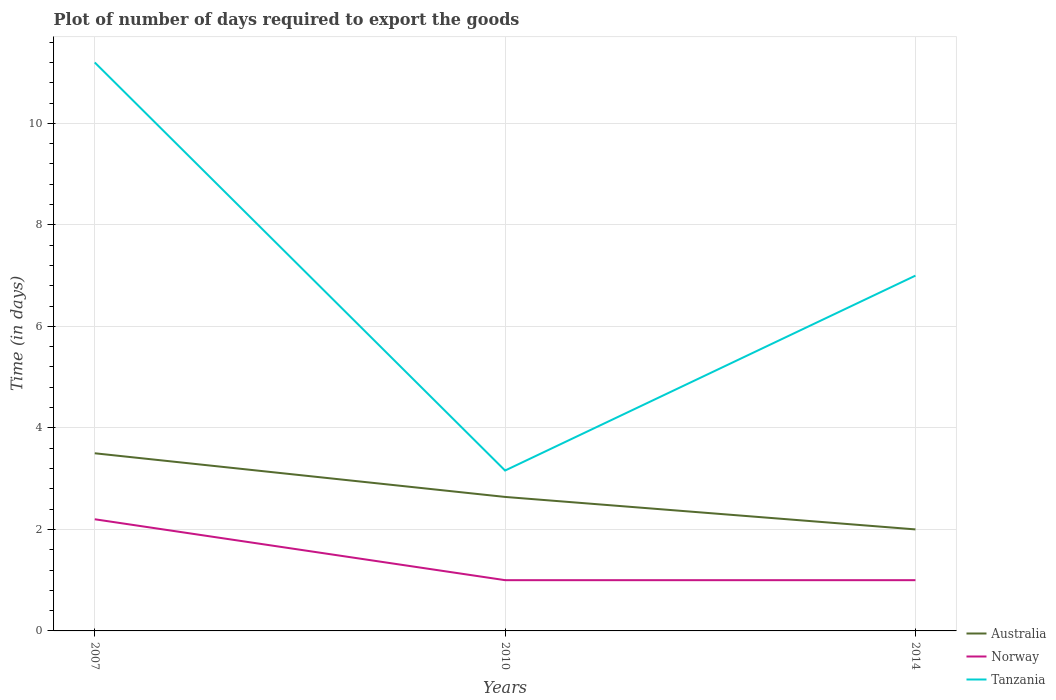Does the line corresponding to Australia intersect with the line corresponding to Tanzania?
Give a very brief answer. No. Is the number of lines equal to the number of legend labels?
Make the answer very short. Yes. Across all years, what is the maximum time required to export goods in Tanzania?
Offer a very short reply. 3.16. What is the total time required to export goods in Australia in the graph?
Offer a terse response. 0.64. What is the difference between the highest and the second highest time required to export goods in Tanzania?
Offer a terse response. 8.04. What is the difference between the highest and the lowest time required to export goods in Tanzania?
Keep it short and to the point. 1. Is the time required to export goods in Norway strictly greater than the time required to export goods in Tanzania over the years?
Provide a succinct answer. Yes. How many lines are there?
Provide a succinct answer. 3. How many years are there in the graph?
Your answer should be very brief. 3. What is the difference between two consecutive major ticks on the Y-axis?
Keep it short and to the point. 2. Are the values on the major ticks of Y-axis written in scientific E-notation?
Offer a very short reply. No. Where does the legend appear in the graph?
Keep it short and to the point. Bottom right. How many legend labels are there?
Give a very brief answer. 3. How are the legend labels stacked?
Provide a succinct answer. Vertical. What is the title of the graph?
Your response must be concise. Plot of number of days required to export the goods. Does "Least developed countries" appear as one of the legend labels in the graph?
Your answer should be compact. No. What is the label or title of the Y-axis?
Offer a very short reply. Time (in days). What is the Time (in days) in Tanzania in 2007?
Your answer should be very brief. 11.2. What is the Time (in days) of Australia in 2010?
Your answer should be very brief. 2.64. What is the Time (in days) in Norway in 2010?
Your answer should be very brief. 1. What is the Time (in days) in Tanzania in 2010?
Keep it short and to the point. 3.16. Across all years, what is the maximum Time (in days) of Tanzania?
Ensure brevity in your answer.  11.2. Across all years, what is the minimum Time (in days) of Tanzania?
Keep it short and to the point. 3.16. What is the total Time (in days) of Australia in the graph?
Your answer should be very brief. 8.14. What is the total Time (in days) of Tanzania in the graph?
Offer a very short reply. 21.36. What is the difference between the Time (in days) of Australia in 2007 and that in 2010?
Make the answer very short. 0.86. What is the difference between the Time (in days) of Tanzania in 2007 and that in 2010?
Offer a very short reply. 8.04. What is the difference between the Time (in days) in Norway in 2007 and that in 2014?
Your answer should be compact. 1.2. What is the difference between the Time (in days) of Tanzania in 2007 and that in 2014?
Ensure brevity in your answer.  4.2. What is the difference between the Time (in days) of Australia in 2010 and that in 2014?
Provide a succinct answer. 0.64. What is the difference between the Time (in days) of Tanzania in 2010 and that in 2014?
Provide a succinct answer. -3.84. What is the difference between the Time (in days) in Australia in 2007 and the Time (in days) in Tanzania in 2010?
Offer a very short reply. 0.34. What is the difference between the Time (in days) of Norway in 2007 and the Time (in days) of Tanzania in 2010?
Ensure brevity in your answer.  -0.96. What is the difference between the Time (in days) of Australia in 2007 and the Time (in days) of Tanzania in 2014?
Keep it short and to the point. -3.5. What is the difference between the Time (in days) in Australia in 2010 and the Time (in days) in Norway in 2014?
Offer a very short reply. 1.64. What is the difference between the Time (in days) in Australia in 2010 and the Time (in days) in Tanzania in 2014?
Your answer should be very brief. -4.36. What is the difference between the Time (in days) of Norway in 2010 and the Time (in days) of Tanzania in 2014?
Ensure brevity in your answer.  -6. What is the average Time (in days) in Australia per year?
Make the answer very short. 2.71. What is the average Time (in days) of Norway per year?
Make the answer very short. 1.4. What is the average Time (in days) of Tanzania per year?
Ensure brevity in your answer.  7.12. In the year 2007, what is the difference between the Time (in days) of Australia and Time (in days) of Tanzania?
Offer a terse response. -7.7. In the year 2010, what is the difference between the Time (in days) of Australia and Time (in days) of Norway?
Offer a terse response. 1.64. In the year 2010, what is the difference between the Time (in days) in Australia and Time (in days) in Tanzania?
Your response must be concise. -0.52. In the year 2010, what is the difference between the Time (in days) in Norway and Time (in days) in Tanzania?
Your answer should be compact. -2.16. In the year 2014, what is the difference between the Time (in days) in Australia and Time (in days) in Tanzania?
Give a very brief answer. -5. What is the ratio of the Time (in days) in Australia in 2007 to that in 2010?
Offer a very short reply. 1.33. What is the ratio of the Time (in days) in Norway in 2007 to that in 2010?
Provide a succinct answer. 2.2. What is the ratio of the Time (in days) in Tanzania in 2007 to that in 2010?
Give a very brief answer. 3.54. What is the ratio of the Time (in days) in Norway in 2007 to that in 2014?
Make the answer very short. 2.2. What is the ratio of the Time (in days) of Tanzania in 2007 to that in 2014?
Offer a very short reply. 1.6. What is the ratio of the Time (in days) in Australia in 2010 to that in 2014?
Give a very brief answer. 1.32. What is the ratio of the Time (in days) in Tanzania in 2010 to that in 2014?
Ensure brevity in your answer.  0.45. What is the difference between the highest and the second highest Time (in days) in Australia?
Offer a terse response. 0.86. What is the difference between the highest and the lowest Time (in days) in Australia?
Give a very brief answer. 1.5. What is the difference between the highest and the lowest Time (in days) of Tanzania?
Offer a terse response. 8.04. 